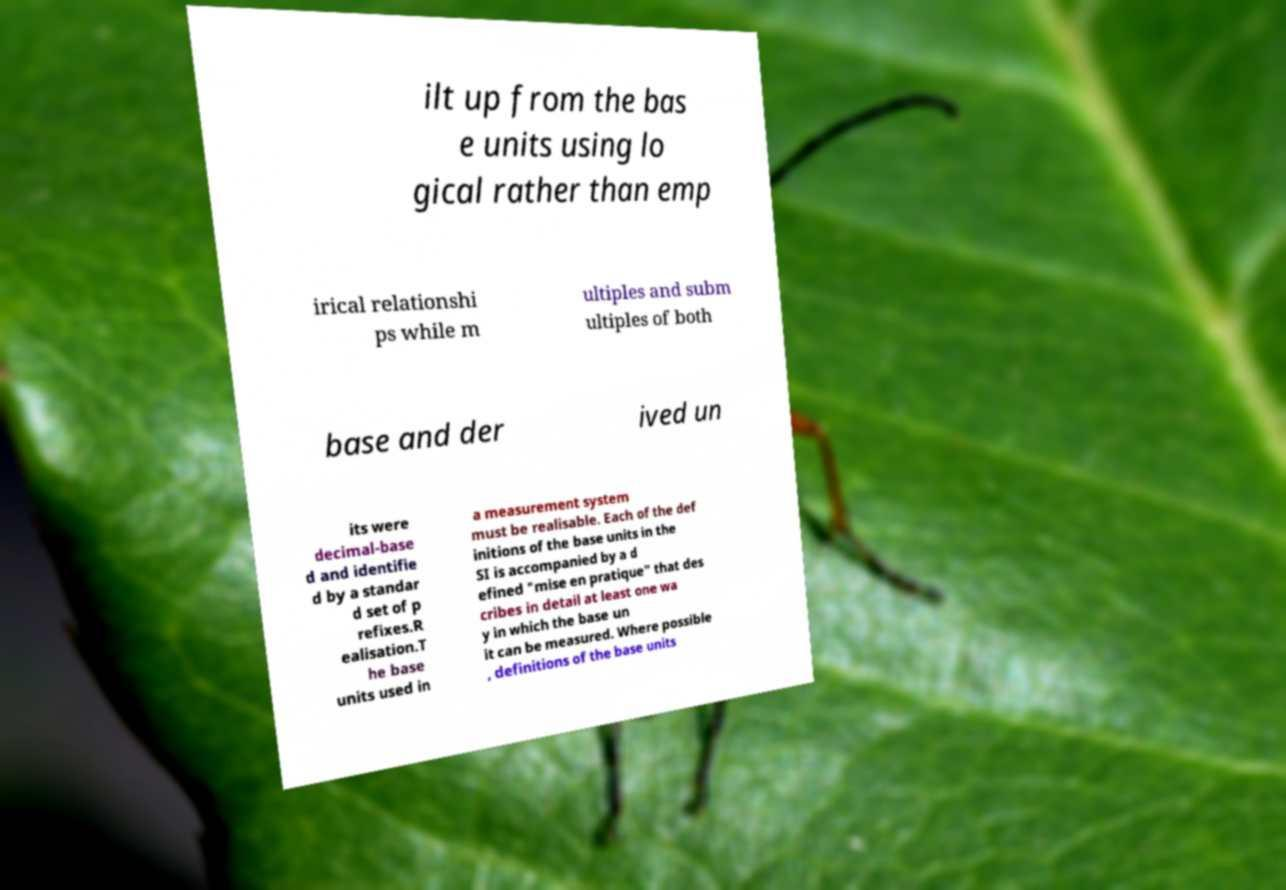For documentation purposes, I need the text within this image transcribed. Could you provide that? ilt up from the bas e units using lo gical rather than emp irical relationshi ps while m ultiples and subm ultiples of both base and der ived un its were decimal-base d and identifie d by a standar d set of p refixes.R ealisation.T he base units used in a measurement system must be realisable. Each of the def initions of the base units in the SI is accompanied by a d efined "mise en pratique" that des cribes in detail at least one wa y in which the base un it can be measured. Where possible , definitions of the base units 